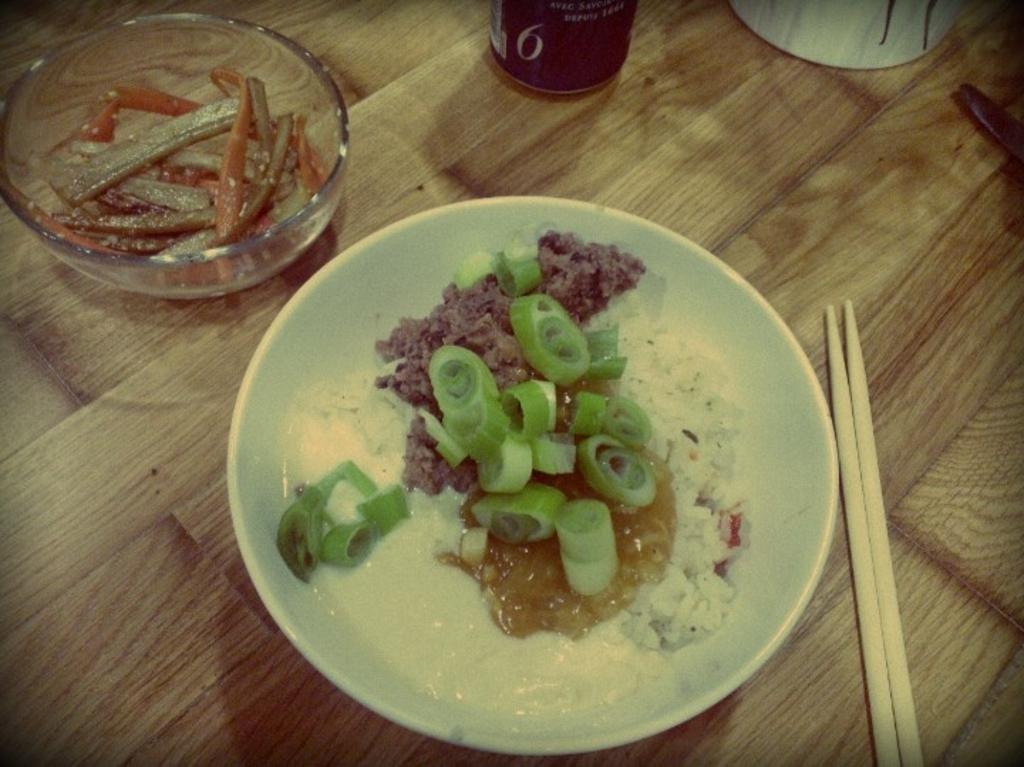Describe this image in one or two sentences. in this picture there are eatables placed in two bowls and there are two Chopsticks placed beside it and there are some other objects in the background. 